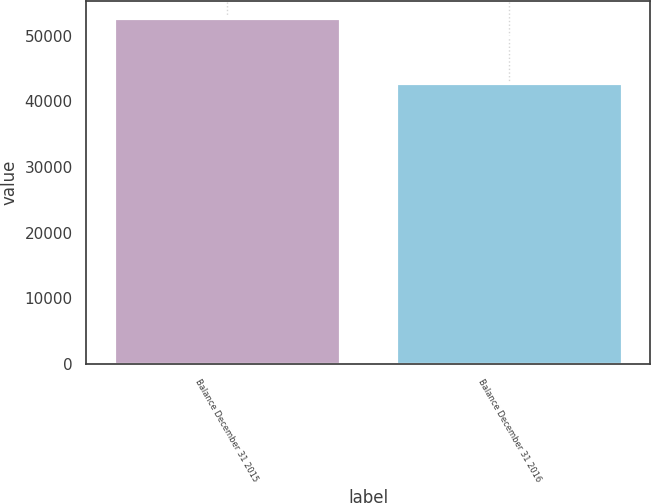<chart> <loc_0><loc_0><loc_500><loc_500><bar_chart><fcel>Balance December 31 2015<fcel>Balance December 31 2016<nl><fcel>52677<fcel>42825<nl></chart> 